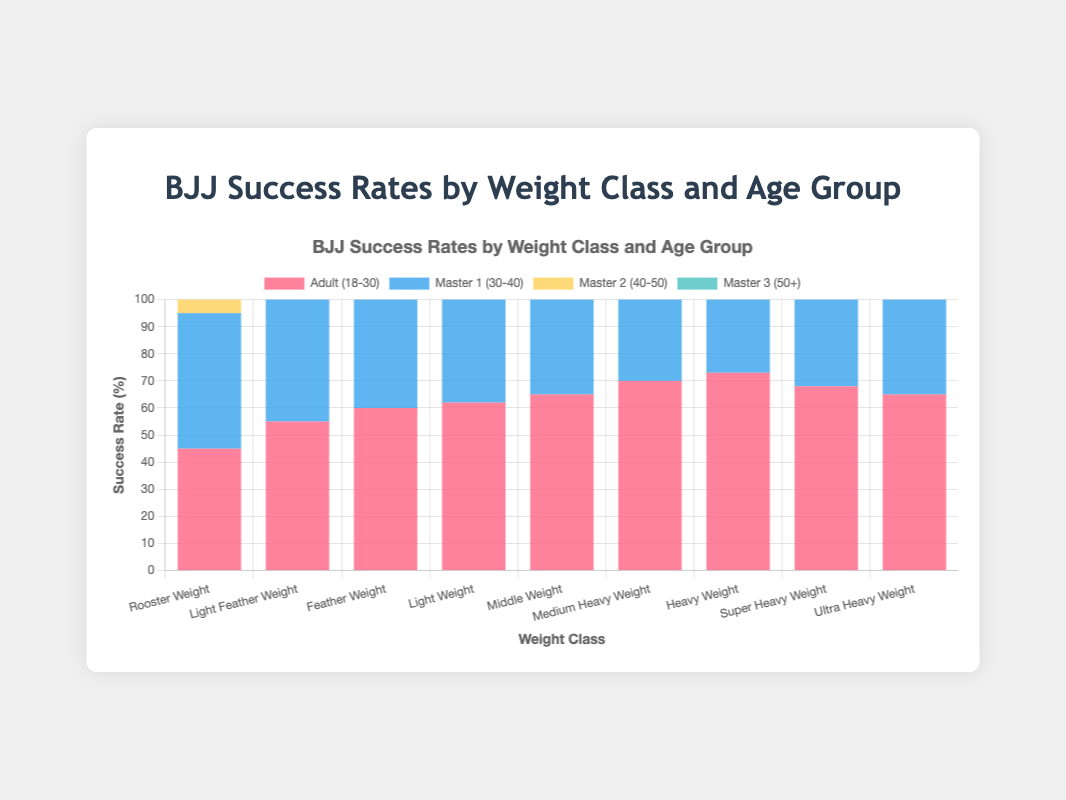Which weight class has the highest success rate for the Adult (18-30) age group? In the stacked bar chart, the red segments represent the Adult (18-30) group. The highest red segment corresponds to the Heavy Weight class at 73%.
Answer: Heavy Weight Which age group has the lowest success rate for the Light Feather Weight class? For Light Feather Weight, the heights and colors of the stacked segments indicate the success rates. The green segment (Master 3, 50+) is the shortest at 43%.
Answer: Master 3 (50+) What is the success rate difference between the Master 3 (50+) age group and the Adult (18-30) age group in the Middle Weight class? The Adult (18-30) group has a success rate of 65%, and the Master 3 (50+) group has a success rate of 52%. The difference is 65% - 52% = 13%.
Answer: 13% Across all weight classes, which age group generally shows a decline in success rate? Observing the colors from bottom to top, success rates generally decrease as we move to older age groups (Master 1, Master 2, Master 3).
Answer: Older age groups Which weight class shows the smallest success rate difference between the Adult (18-30) and Master 2 (40-50) age groups? The Rooster Weight class shows 45% for Adult and 40% for Master 2, a difference of 5%, which is the smallest among all classes.
Answer: Rooster Weight What is the combined success rate for the Ultra Heavy Weight class for all age groups? Summing up the segments: 65% (Adult) + 63% (Master 1) + 57% (Master 2) + 50% (Master 3) = 235%.
Answer: 235% In which weight class do Master 1 (30-40) competitors have the highest relative advantage over Master 3 (50+) competitors? Compare the blue segment (Master 1) to the green segment (Master 3) in each class. The Rooster Weight class has 50% (Master 1) and 35% (Master 3), a difference of 15%, which is the highest.
Answer: Rooster Weight Is there any correlation between increased weight class and success rate for the Adult (18-30) group? For Adults (18-30), represented by the red segments, success rate generally increases from Rooster Weight (45%) to Heavy Weight (73%), indicating a correlation.
Answer: Yes Calculate the average success rate across all age groups for the Feather Weight class. Add the success rates for all age groups: 60% (Adult) + 58% (Master 1) + 53% (Master 2) + 47% (Master 3) = 218%. Then divide by 4 age groups: 218% / 4 = 54.5%.
Answer: 54.5% Which weight class shows the most balanced success rates across all age groups? By visually comparing the height difference among different colors, the Super Heavy Weight class has more balanced segment heights (68%, 65%, 60%, 55%).
Answer: Super Heavy Weight 